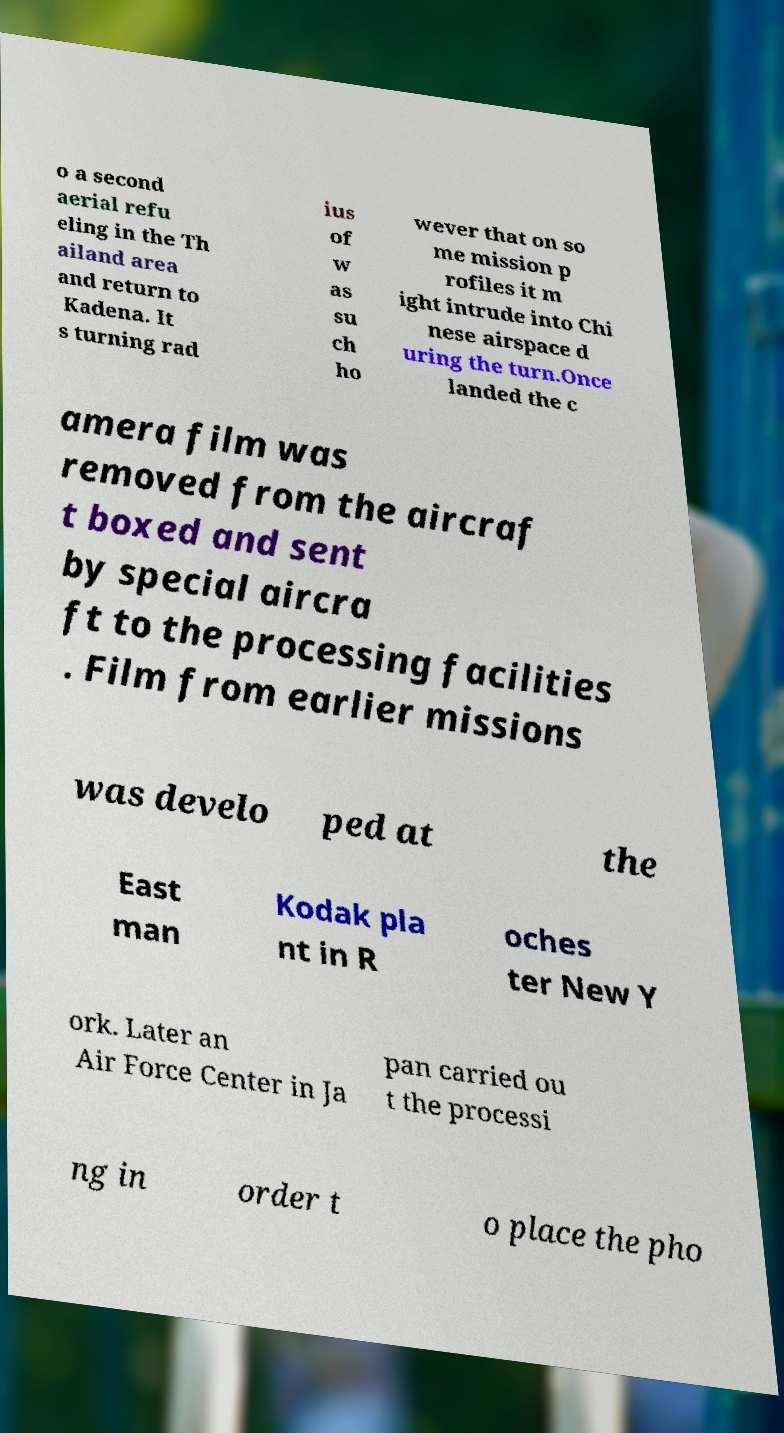Could you assist in decoding the text presented in this image and type it out clearly? o a second aerial refu eling in the Th ailand area and return to Kadena. It s turning rad ius of w as su ch ho wever that on so me mission p rofiles it m ight intrude into Chi nese airspace d uring the turn.Once landed the c amera film was removed from the aircraf t boxed and sent by special aircra ft to the processing facilities . Film from earlier missions was develo ped at the East man Kodak pla nt in R oches ter New Y ork. Later an Air Force Center in Ja pan carried ou t the processi ng in order t o place the pho 